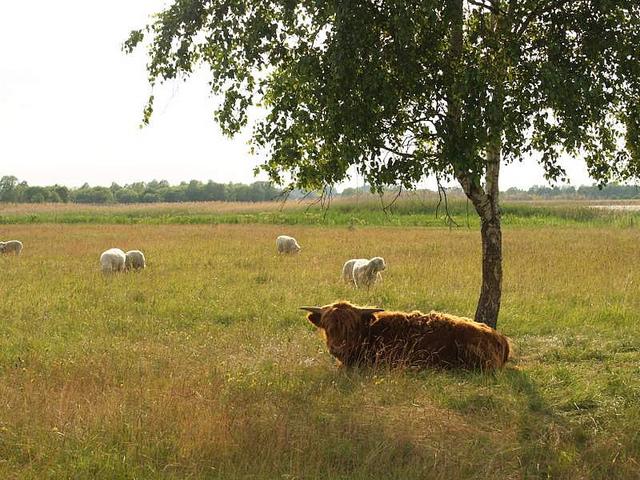Is the oxen laying down?
Keep it brief. Yes. Why does this oxen stand out?
Concise answer only. Color. What kind of tree is this?
Quick response, please. Oak. 